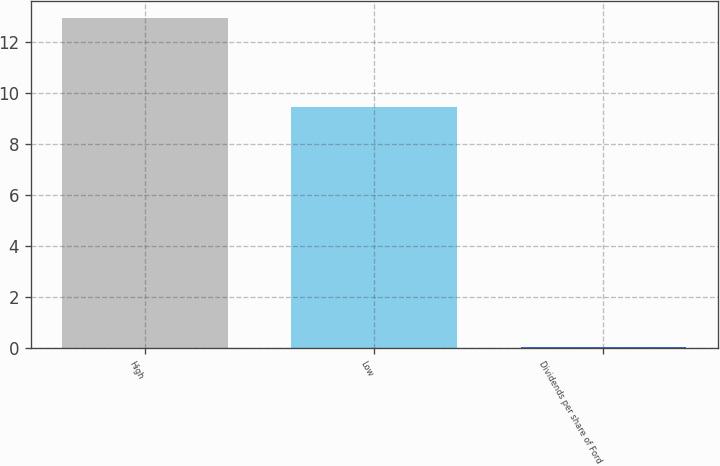Convert chart. <chart><loc_0><loc_0><loc_500><loc_500><bar_chart><fcel>High<fcel>Low<fcel>Dividends per share of Ford<nl><fcel>12.95<fcel>9.46<fcel>0.05<nl></chart> 